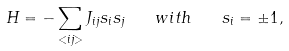Convert formula to latex. <formula><loc_0><loc_0><loc_500><loc_500>H = - \sum _ { < i j > } J _ { i j } s _ { i } s _ { j } \quad w i t h \quad s _ { i } = \pm 1 ,</formula> 